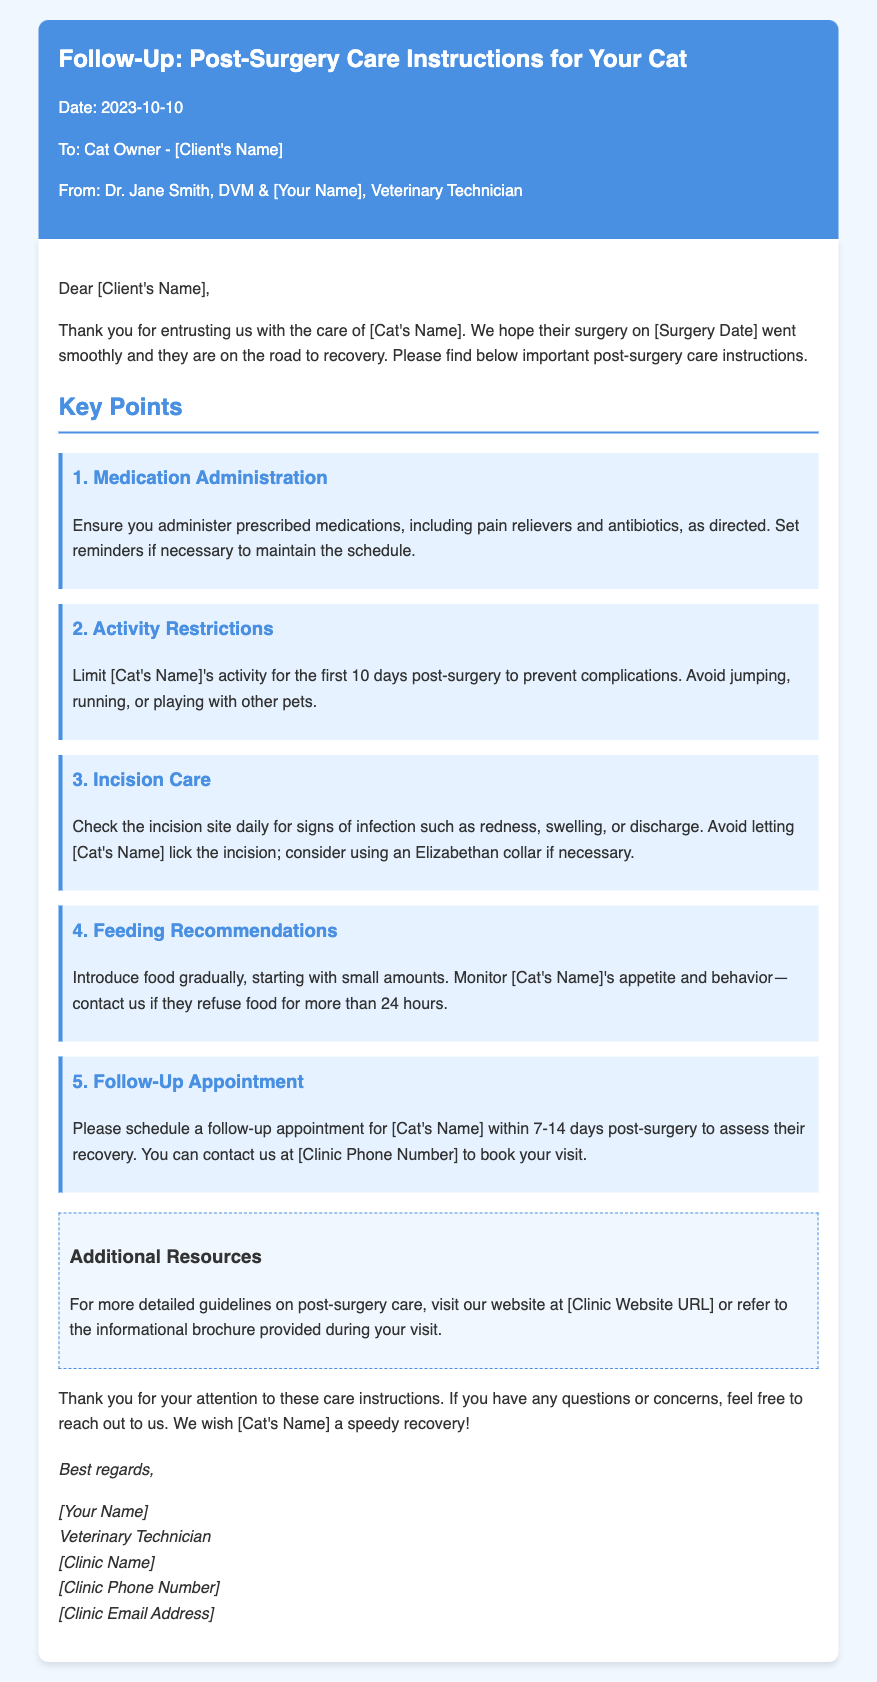What is the date of the memo? The date of the memo is explicitly stated within the document as "2023-10-10."
Answer: 2023-10-10 Who is the veterinarian mentioned in the memo? The memo mentions Dr. Jane Smith, DVM, as the veterinarian responsible for the care of the cat.
Answer: Dr. Jane Smith What should be monitored regarding the incision site? The memo advises checking for signs of infection such as redness, swelling, or discharge at the incision site.
Answer: Signs of infection How long should activity be limited post-surgery? The document specifies that the cat's activity should be limited for the first 10 days post-surgery to prevent complications.
Answer: 10 days What is the contact method for scheduling the follow-up appointment? The memo states that the client can contact the clinic via phone to book the follow-up appointment.
Answer: Phone What type of collar is recommended if the cat licks the incision? The memo suggests considering the use of an Elizabethan collar if necessary to prevent licking the incision.
Answer: Elizabethan collar What should the client do if their cat refuses food? The document states that the client should contact the clinic if the cat refuses food for more than 24 hours.
Answer: Contact the clinic What should be introduced gradually after surgery? The memo indicates that food should be introduced gradually, starting with small amounts.
Answer: Food What additional resources are provided in the memo? The document mentions that more detailed guidelines on post-surgery care can be found on the clinic's website or in an informational brochure.
Answer: Clinic website and brochure 